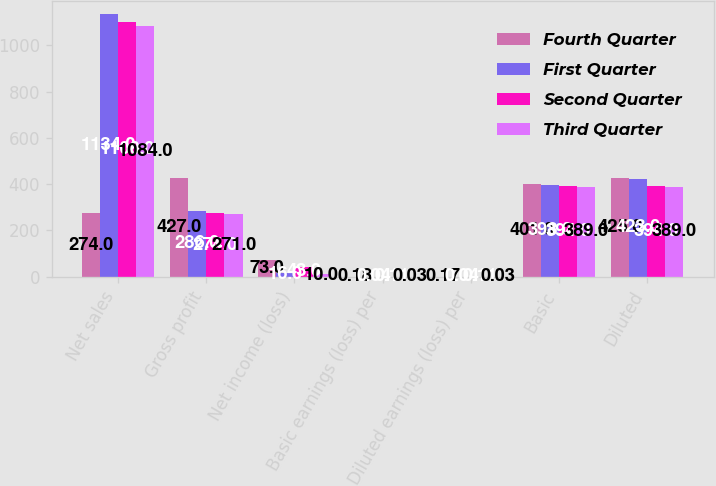Convert chart. <chart><loc_0><loc_0><loc_500><loc_500><stacked_bar_chart><ecel><fcel>Net sales<fcel>Gross profit<fcel>Net income (loss)<fcel>Basic earnings (loss) per<fcel>Diluted earnings (loss) per<fcel>Basic<fcel>Diluted<nl><fcel>Fourth Quarter<fcel>274<fcel>427<fcel>73<fcel>0.18<fcel>0.17<fcel>401<fcel>425<nl><fcel>First Quarter<fcel>1134<fcel>286<fcel>16<fcel>0.04<fcel>0.04<fcel>398<fcel>423<nl><fcel>Second Quarter<fcel>1100<fcel>274<fcel>43<fcel>0.11<fcel>0.11<fcel>394<fcel>394<nl><fcel>Third Quarter<fcel>1084<fcel>271<fcel>10<fcel>0.03<fcel>0.03<fcel>389<fcel>389<nl></chart> 